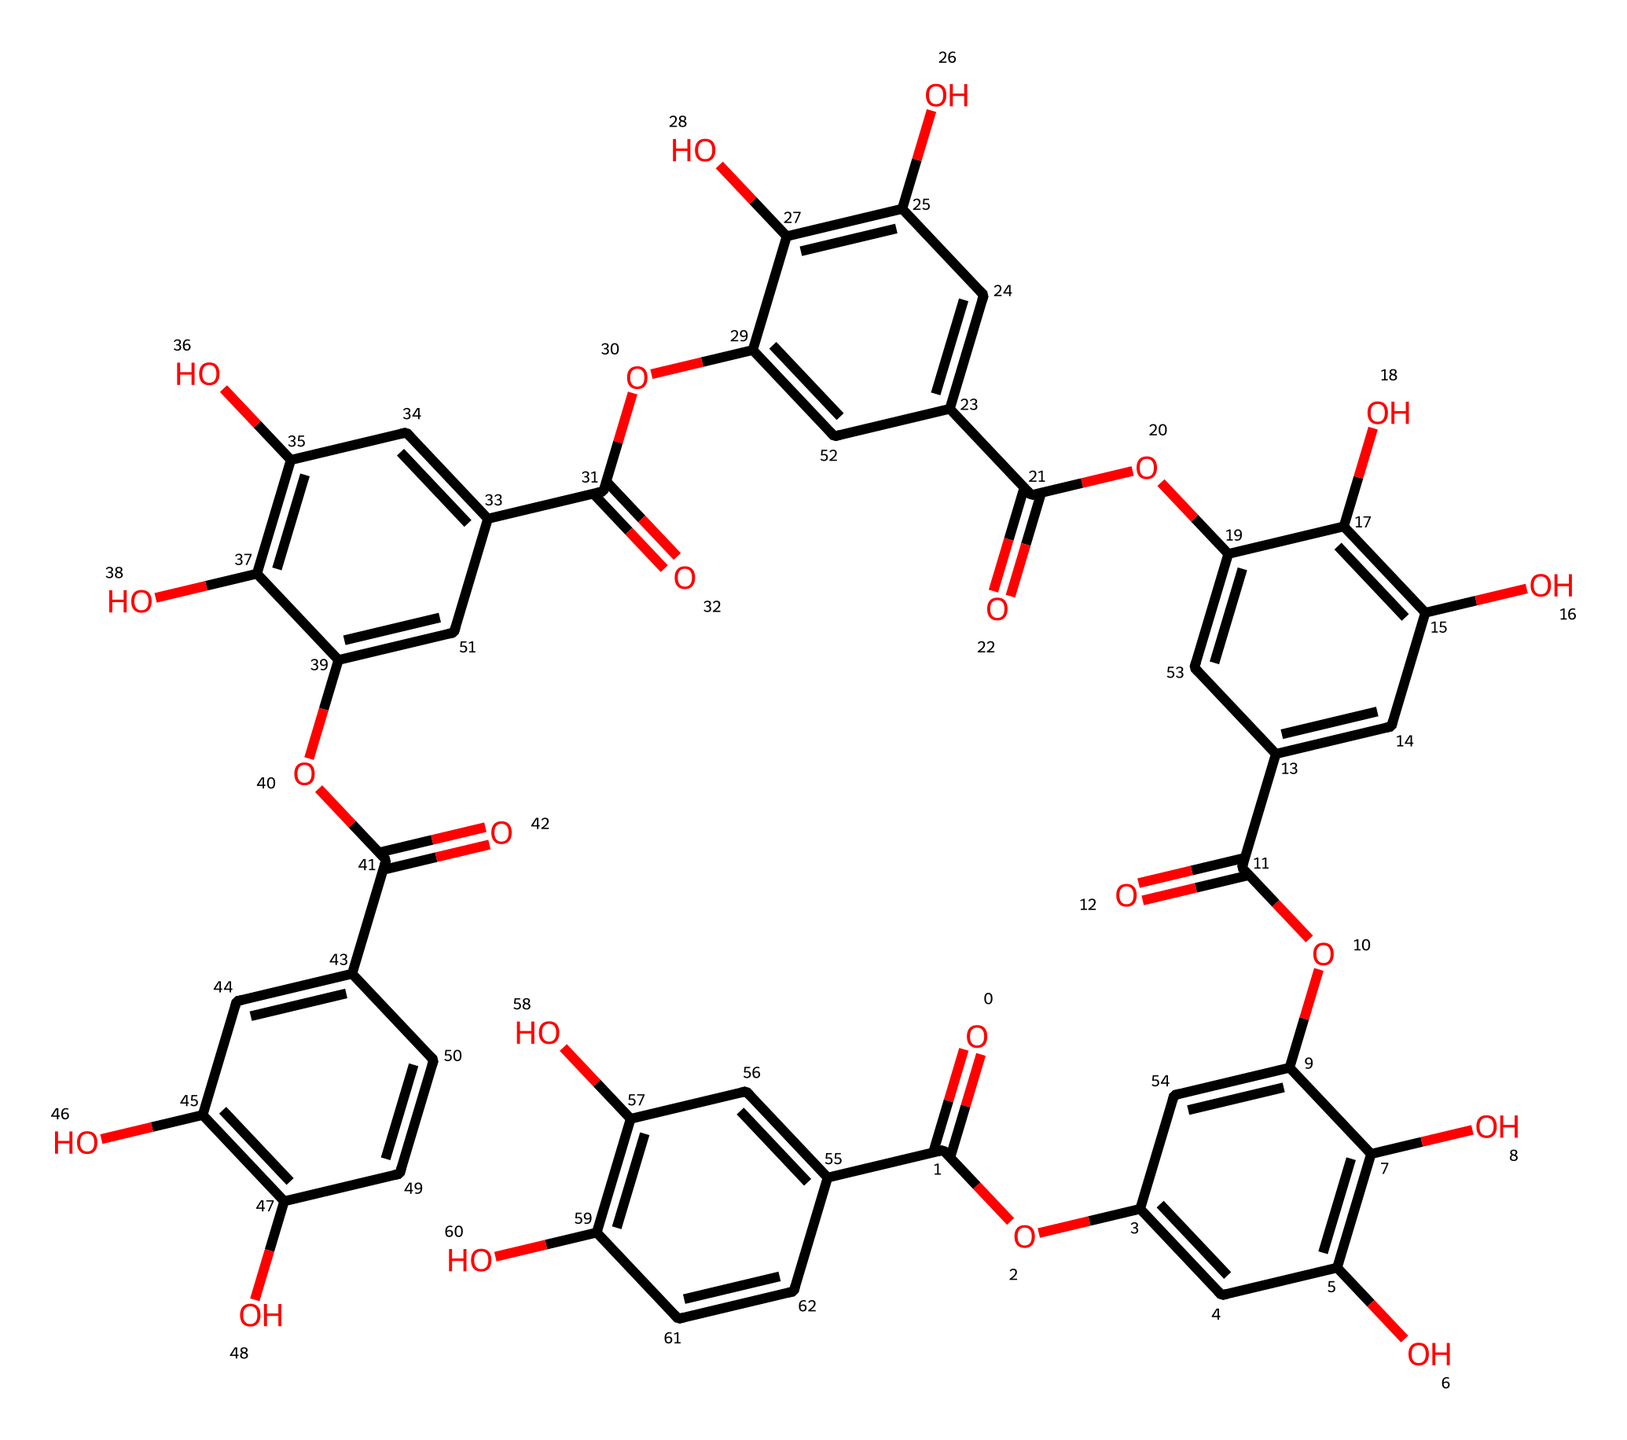What is the primary functional group present in tannic acid? The SMILES representation shows several -COOH (carboxylic acid) groups throughout the structure, indicating the presence of carboxylic acid functional groups.
Answer: carboxylic acid How many phenolic units can be identified in the structure of tannic acid? By examining the multiple aromatic rings in the SMILES, we can count a total of five phenolic units based on the repeating structure and hydroxyl (-OH) groups attached to the rings.
Answer: five What is the total number of oxygen atoms in tannic acid? By analyzing the SMILES structure, we can identify that there are a total of 10 oxygen atoms present throughout the carboxylic acid and ether functional groups.
Answer: ten What type of acid is tannic acid classified as? Upon reviewing the structure, particularly focusing on the presence of multiple carboxylic acid groups, tannic acid is classified as a polyphenolic acid due to its structure and properties.
Answer: polyphenolic acid What characteristic of tannic acid contributes to its astringent taste? The presence of multiple hydroxyl (-OH) groups and carboxylic acid functional groups leads to astringency by interacting with proteins, which can be deduced from their spatial arrangement in the molecule.
Answer: interaction with proteins 